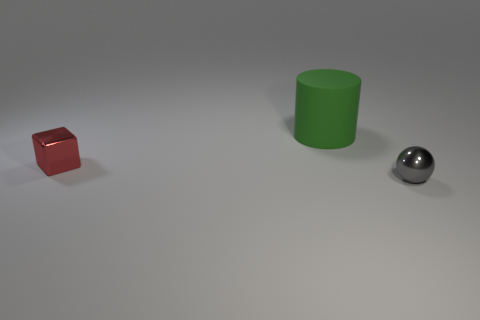Are there any other things that have the same size as the green rubber cylinder?
Give a very brief answer. No. Do the rubber object and the cube have the same size?
Your answer should be compact. No. What shape is the large rubber thing on the right side of the small metal object on the left side of the gray object to the right of the big object?
Give a very brief answer. Cylinder. There is a small shiny thing in front of the small red metallic thing; is it the same color as the small metallic object that is to the left of the big thing?
Make the answer very short. No. What is the material of the gray thing that is the same size as the red metal object?
Make the answer very short. Metal. Are there any green cylinders of the same size as the gray metallic ball?
Provide a succinct answer. No. Are there fewer tiny gray balls that are behind the small red shiny block than large green cylinders?
Ensure brevity in your answer.  Yes. Are there fewer large green things left of the green thing than red objects behind the tiny red cube?
Provide a short and direct response. No. What number of cylinders are red things or small gray objects?
Provide a short and direct response. 0. Are the small thing left of the cylinder and the thing behind the red thing made of the same material?
Make the answer very short. No. 